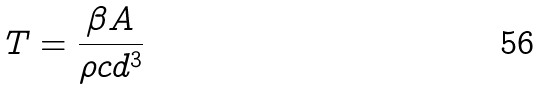Convert formula to latex. <formula><loc_0><loc_0><loc_500><loc_500>T = \frac { \beta A } { \rho c d ^ { 3 } }</formula> 